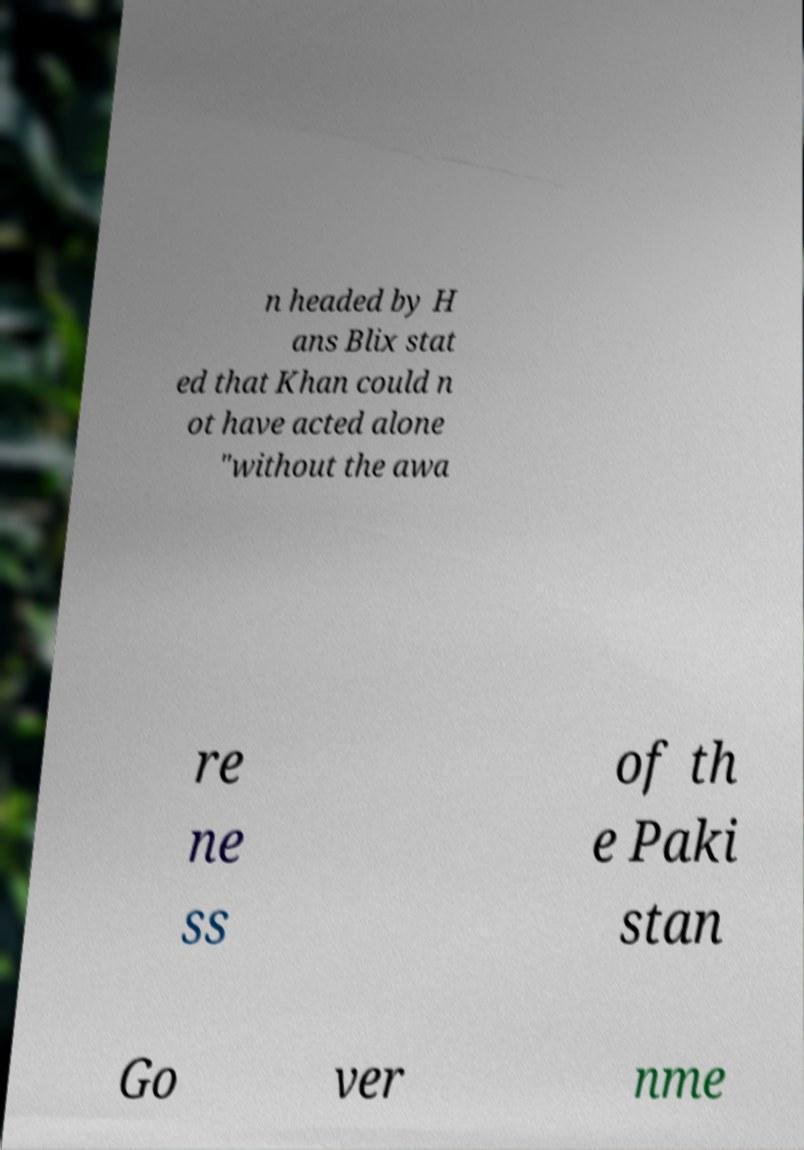Please read and relay the text visible in this image. What does it say? n headed by H ans Blix stat ed that Khan could n ot have acted alone "without the awa re ne ss of th e Paki stan Go ver nme 